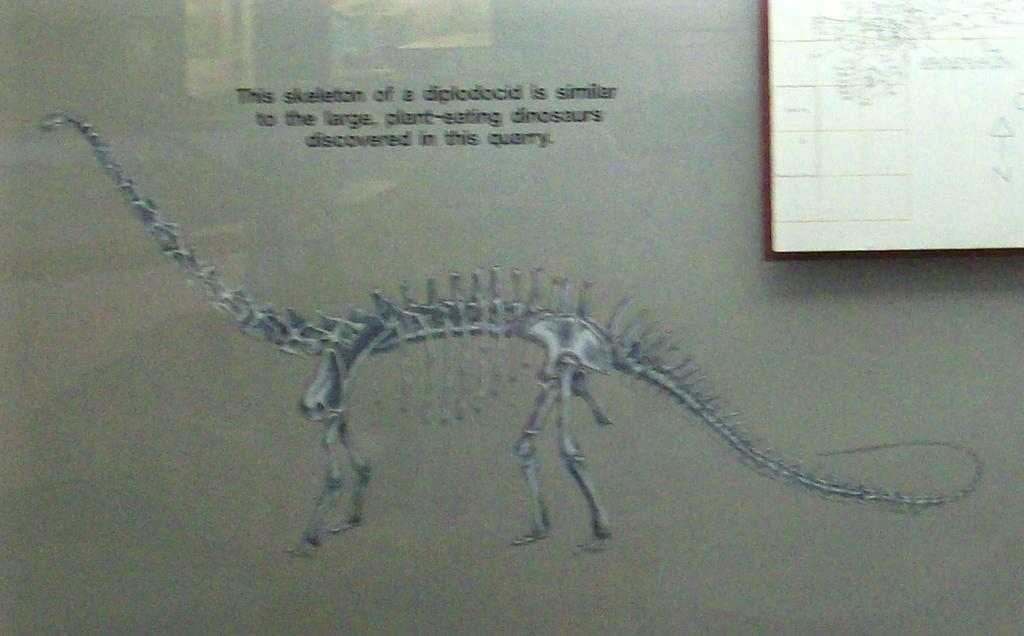Provide a one-sentence caption for the provided image. A dinosaur skeleton is shown along with text that says this dinosaur is similar to the large plant-eating dinosaurs. 